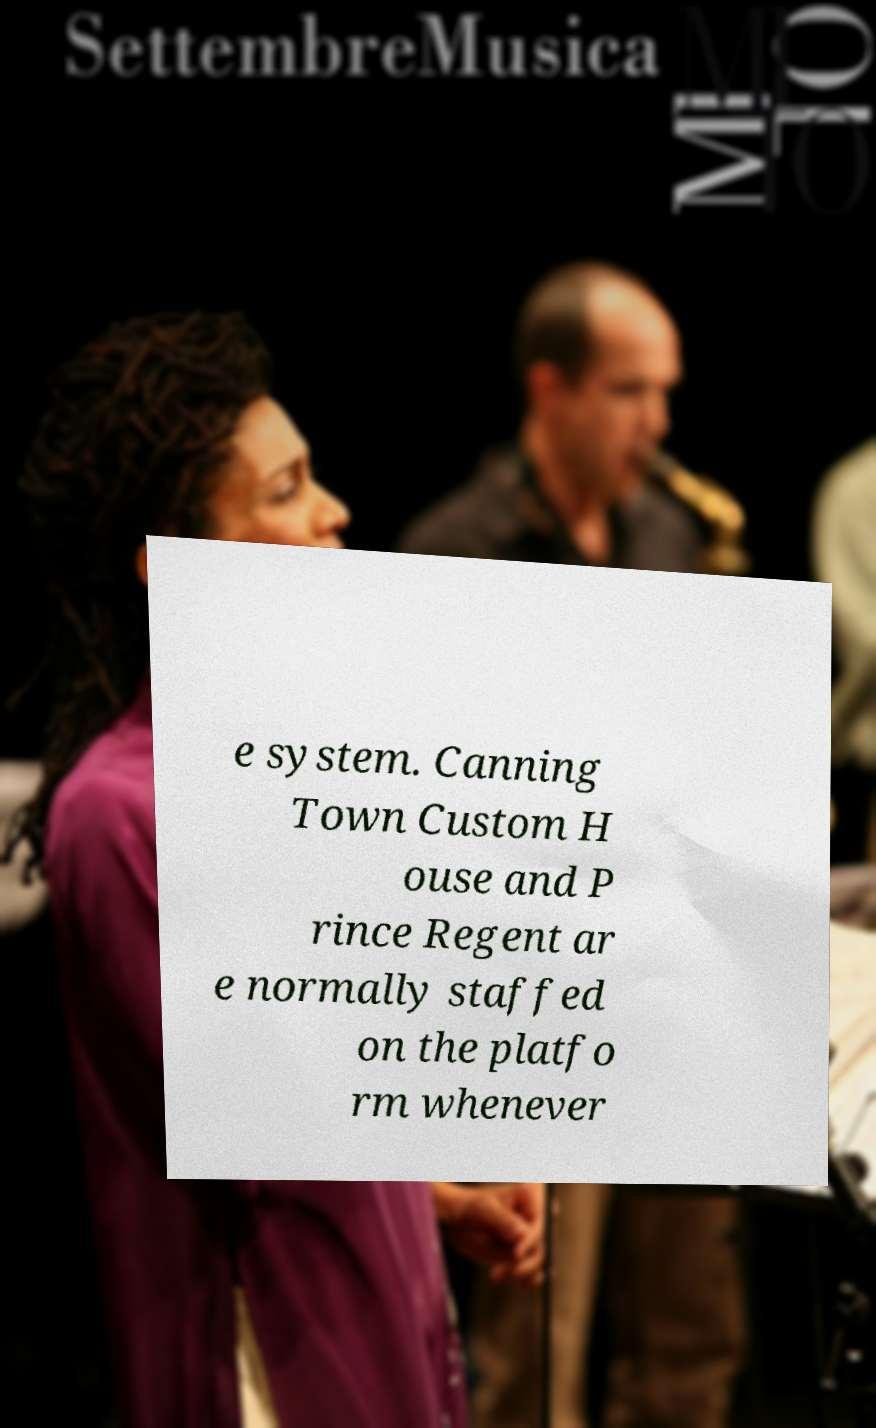Can you read and provide the text displayed in the image?This photo seems to have some interesting text. Can you extract and type it out for me? e system. Canning Town Custom H ouse and P rince Regent ar e normally staffed on the platfo rm whenever 